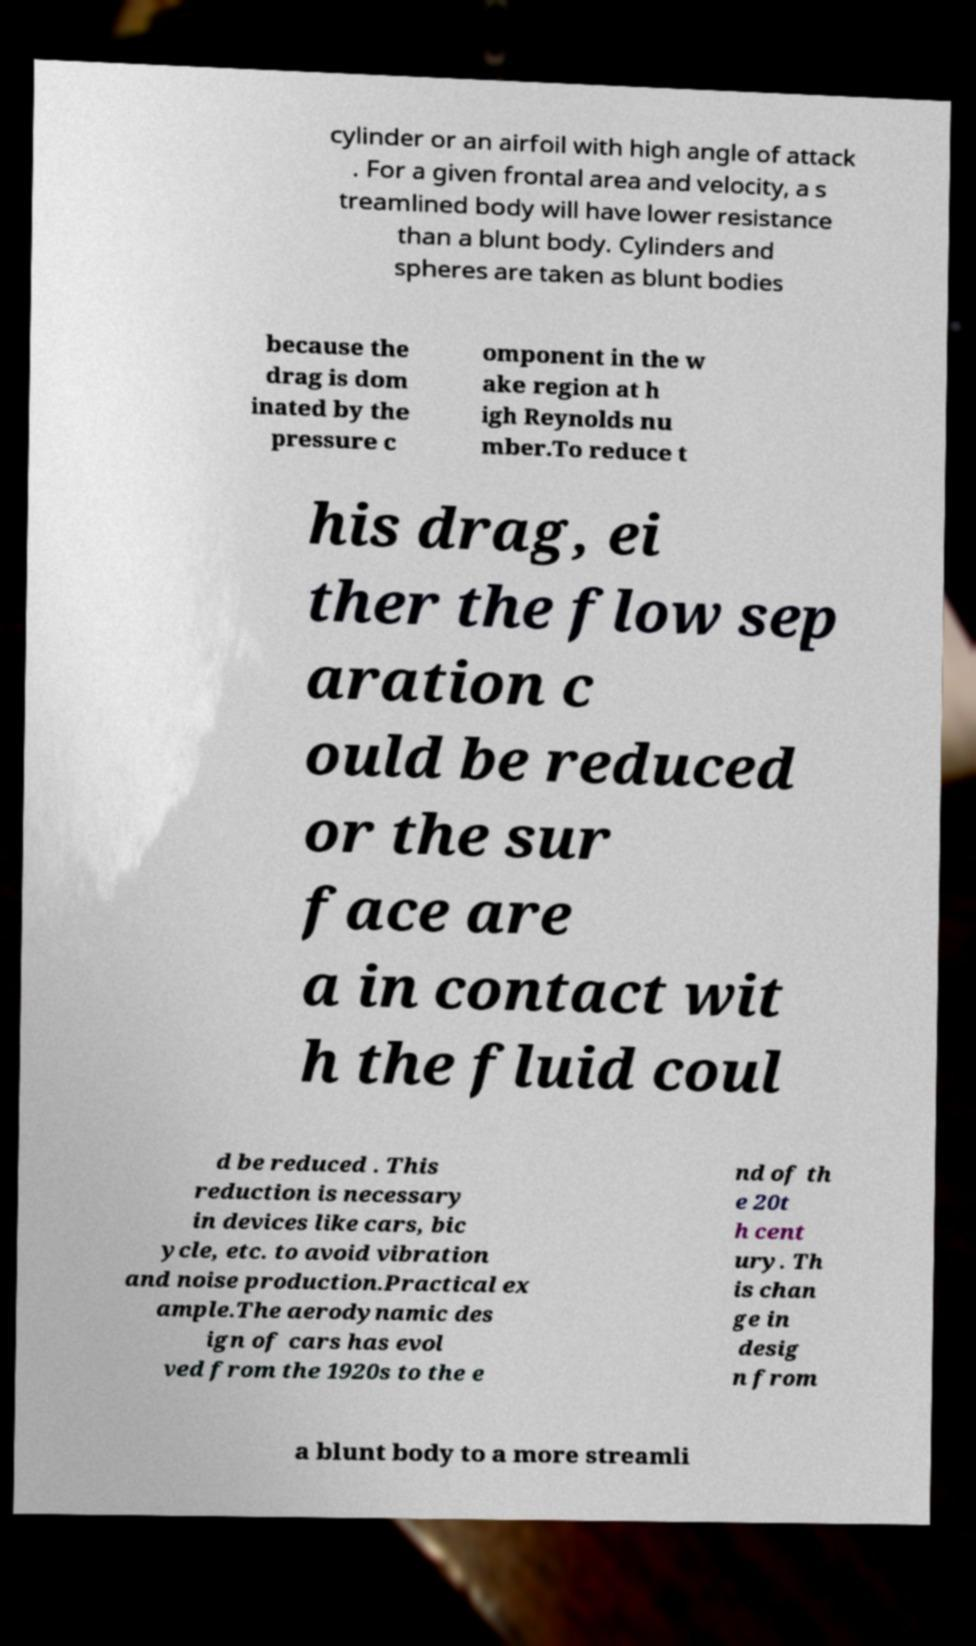Please read and relay the text visible in this image. What does it say? cylinder or an airfoil with high angle of attack . For a given frontal area and velocity, a s treamlined body will have lower resistance than a blunt body. Cylinders and spheres are taken as blunt bodies because the drag is dom inated by the pressure c omponent in the w ake region at h igh Reynolds nu mber.To reduce t his drag, ei ther the flow sep aration c ould be reduced or the sur face are a in contact wit h the fluid coul d be reduced . This reduction is necessary in devices like cars, bic ycle, etc. to avoid vibration and noise production.Practical ex ample.The aerodynamic des ign of cars has evol ved from the 1920s to the e nd of th e 20t h cent ury. Th is chan ge in desig n from a blunt body to a more streamli 